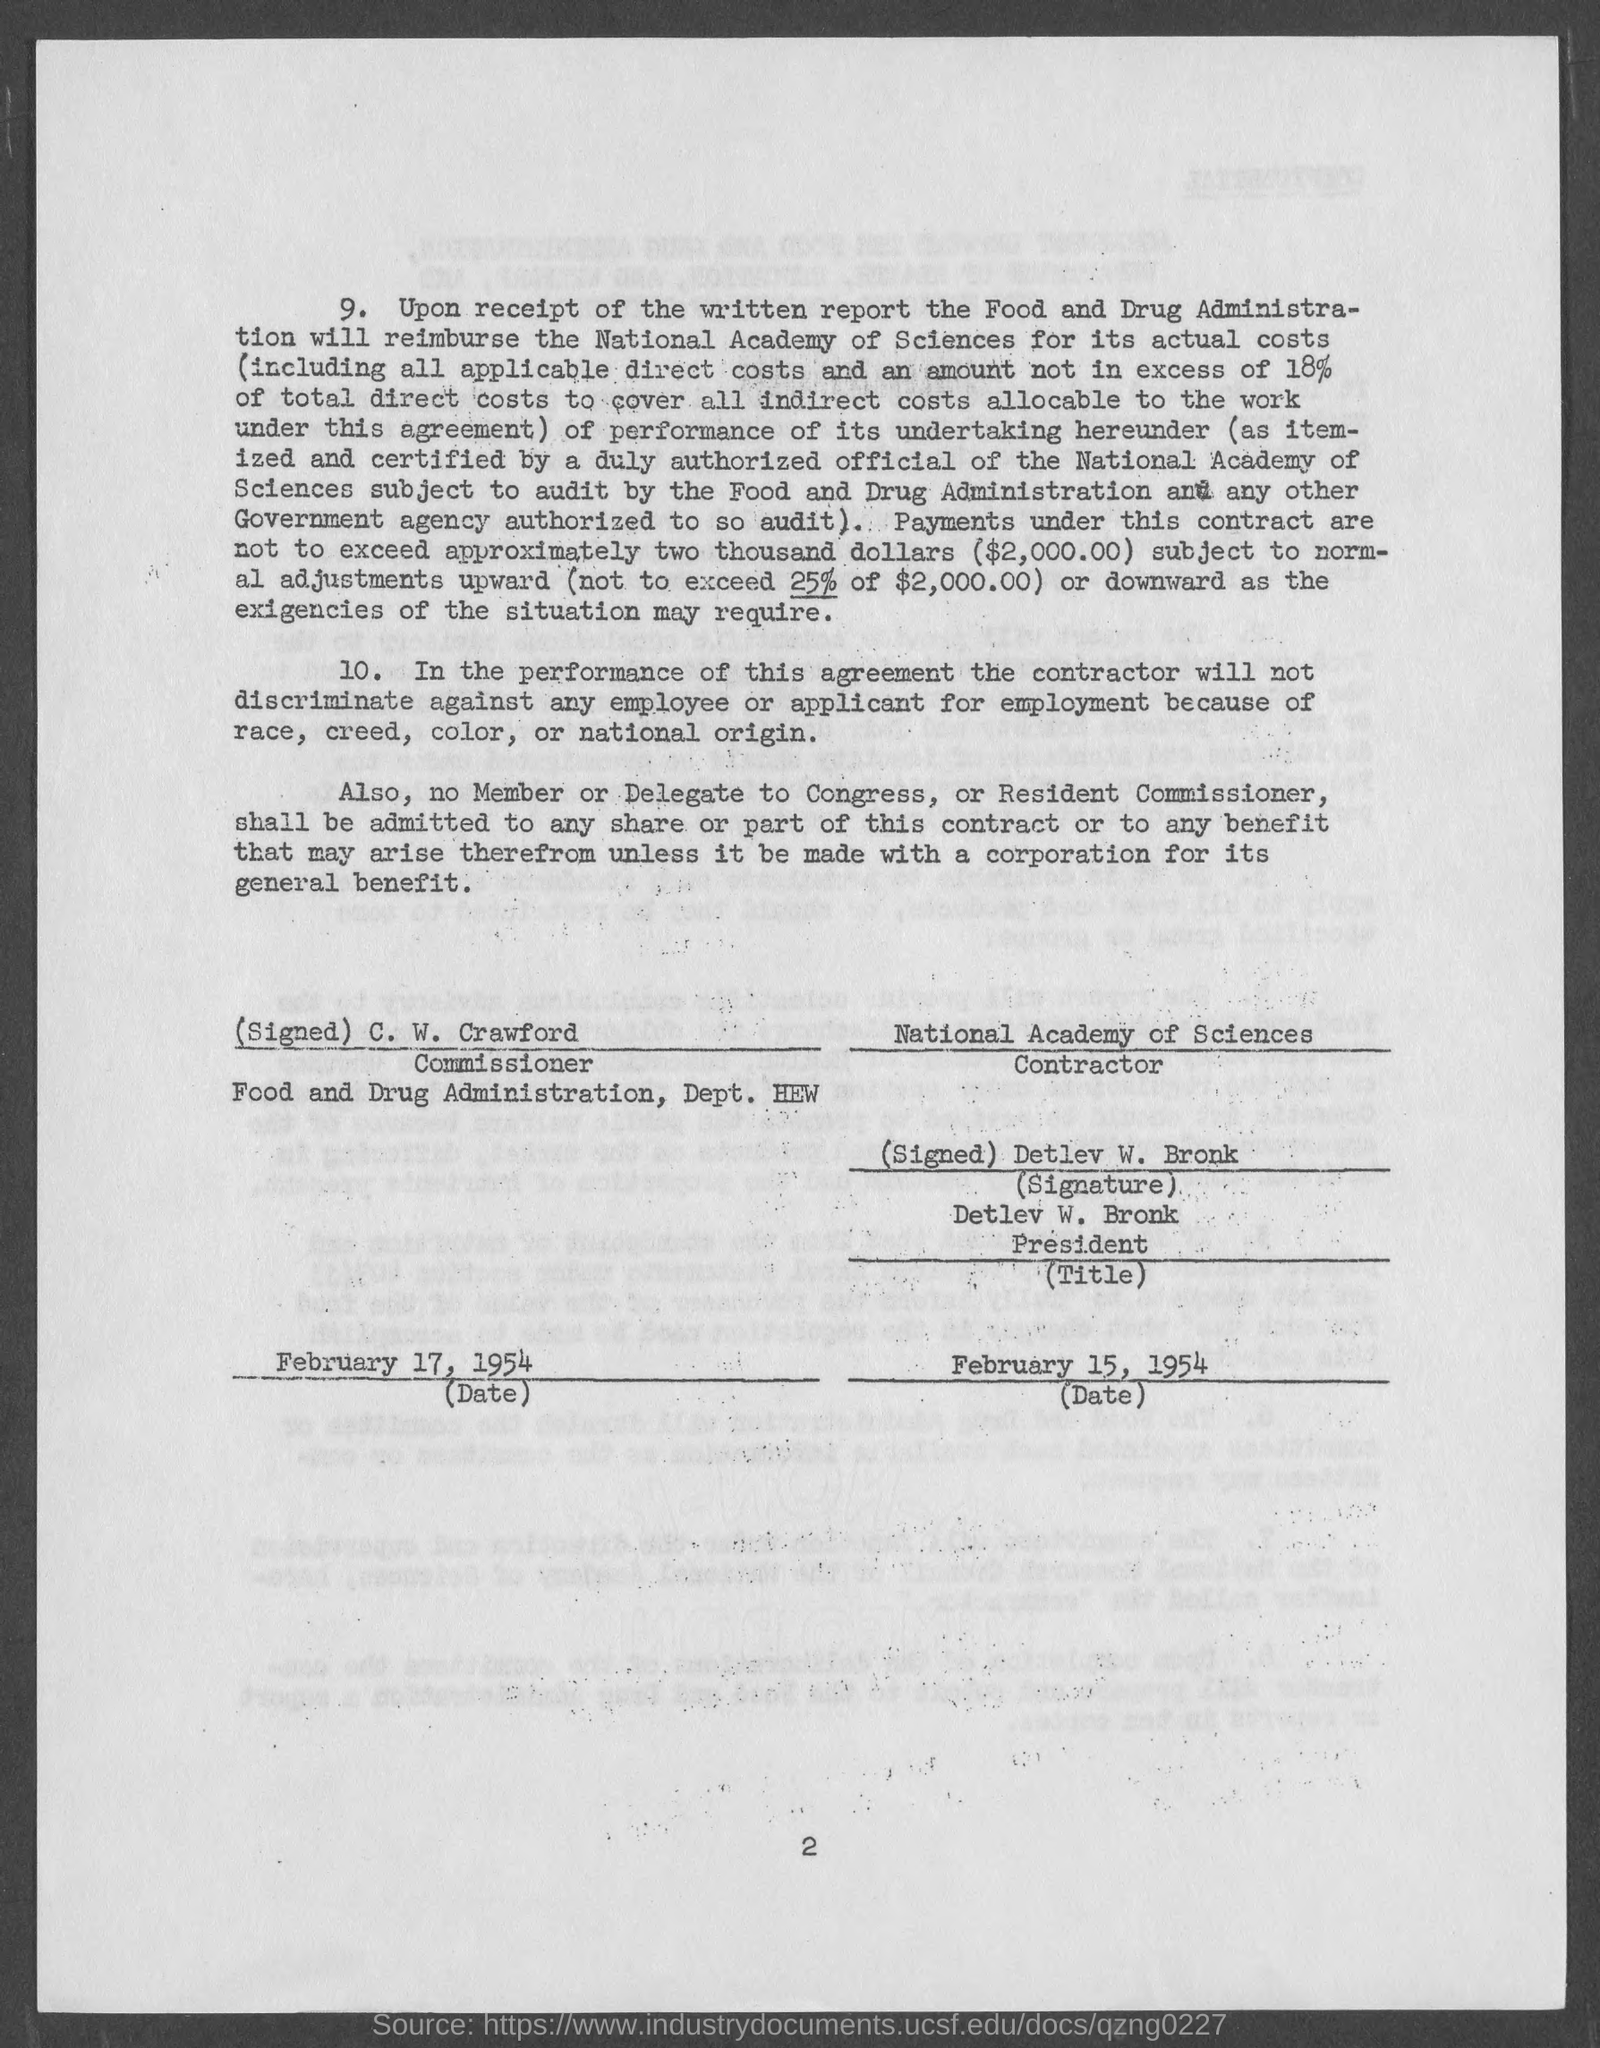Who will reimburse National academy of Sciences for its actual costs?
Give a very brief answer. Food and Drug Administra-tion. Who is the Commissioner?
Give a very brief answer. C. W. Crawford. Who is the Contractor?
Your answer should be compact. National Academy of Sciences. 